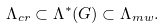Convert formula to latex. <formula><loc_0><loc_0><loc_500><loc_500>\Lambda _ { c r } \subset \Lambda ^ { * } ( G ) \subset \Lambda _ { m w } .</formula> 